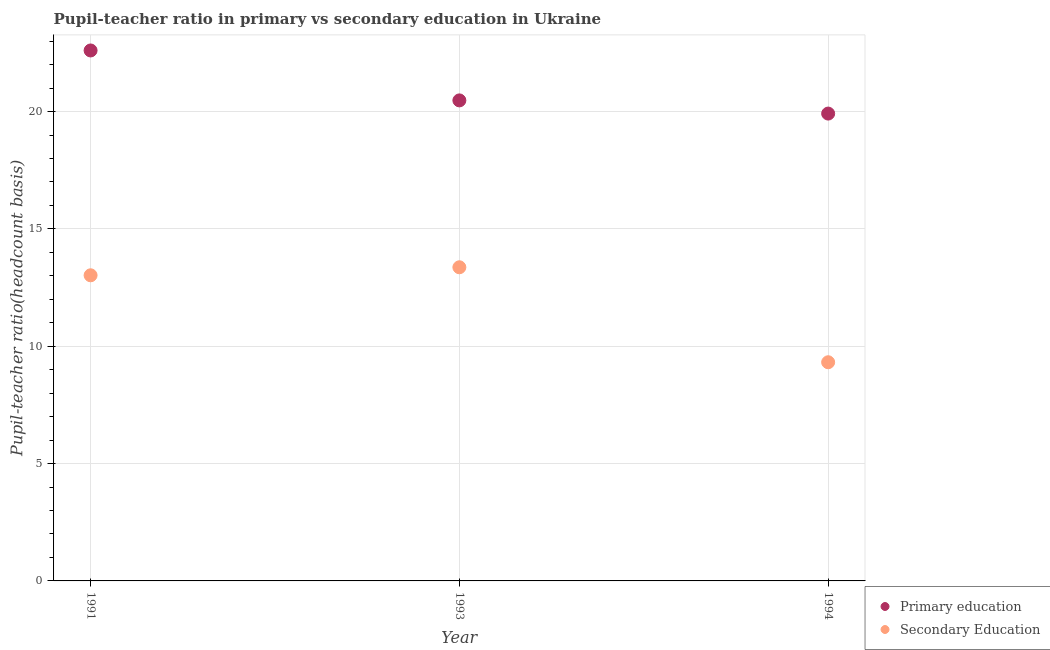How many different coloured dotlines are there?
Give a very brief answer. 2. What is the pupil-teacher ratio in primary education in 1993?
Make the answer very short. 20.48. Across all years, what is the maximum pupil teacher ratio on secondary education?
Provide a succinct answer. 13.37. Across all years, what is the minimum pupil teacher ratio on secondary education?
Give a very brief answer. 9.32. In which year was the pupil teacher ratio on secondary education minimum?
Your answer should be very brief. 1994. What is the total pupil teacher ratio on secondary education in the graph?
Provide a short and direct response. 35.71. What is the difference between the pupil teacher ratio on secondary education in 1991 and that in 1994?
Your response must be concise. 3.71. What is the difference between the pupil-teacher ratio in primary education in 1993 and the pupil teacher ratio on secondary education in 1991?
Your answer should be compact. 7.45. What is the average pupil-teacher ratio in primary education per year?
Provide a succinct answer. 21. In the year 1994, what is the difference between the pupil-teacher ratio in primary education and pupil teacher ratio on secondary education?
Your answer should be very brief. 10.6. What is the ratio of the pupil-teacher ratio in primary education in 1991 to that in 1994?
Give a very brief answer. 1.14. Is the pupil teacher ratio on secondary education in 1991 less than that in 1994?
Your answer should be compact. No. Is the difference between the pupil-teacher ratio in primary education in 1993 and 1994 greater than the difference between the pupil teacher ratio on secondary education in 1993 and 1994?
Give a very brief answer. No. What is the difference between the highest and the second highest pupil teacher ratio on secondary education?
Give a very brief answer. 0.34. What is the difference between the highest and the lowest pupil-teacher ratio in primary education?
Ensure brevity in your answer.  2.69. Is the sum of the pupil-teacher ratio in primary education in 1991 and 1994 greater than the maximum pupil teacher ratio on secondary education across all years?
Ensure brevity in your answer.  Yes. Does the pupil teacher ratio on secondary education monotonically increase over the years?
Make the answer very short. No. Are the values on the major ticks of Y-axis written in scientific E-notation?
Offer a terse response. No. Does the graph contain any zero values?
Your response must be concise. No. Where does the legend appear in the graph?
Your response must be concise. Bottom right. How many legend labels are there?
Offer a terse response. 2. What is the title of the graph?
Keep it short and to the point. Pupil-teacher ratio in primary vs secondary education in Ukraine. What is the label or title of the Y-axis?
Give a very brief answer. Pupil-teacher ratio(headcount basis). What is the Pupil-teacher ratio(headcount basis) in Primary education in 1991?
Keep it short and to the point. 22.6. What is the Pupil-teacher ratio(headcount basis) of Secondary Education in 1991?
Your answer should be compact. 13.02. What is the Pupil-teacher ratio(headcount basis) of Primary education in 1993?
Provide a short and direct response. 20.48. What is the Pupil-teacher ratio(headcount basis) in Secondary Education in 1993?
Your answer should be very brief. 13.37. What is the Pupil-teacher ratio(headcount basis) of Primary education in 1994?
Your response must be concise. 19.92. What is the Pupil-teacher ratio(headcount basis) in Secondary Education in 1994?
Make the answer very short. 9.32. Across all years, what is the maximum Pupil-teacher ratio(headcount basis) in Primary education?
Offer a terse response. 22.6. Across all years, what is the maximum Pupil-teacher ratio(headcount basis) in Secondary Education?
Offer a very short reply. 13.37. Across all years, what is the minimum Pupil-teacher ratio(headcount basis) of Primary education?
Make the answer very short. 19.92. Across all years, what is the minimum Pupil-teacher ratio(headcount basis) in Secondary Education?
Your answer should be very brief. 9.32. What is the total Pupil-teacher ratio(headcount basis) in Primary education in the graph?
Make the answer very short. 63. What is the total Pupil-teacher ratio(headcount basis) in Secondary Education in the graph?
Your answer should be compact. 35.71. What is the difference between the Pupil-teacher ratio(headcount basis) of Primary education in 1991 and that in 1993?
Provide a short and direct response. 2.13. What is the difference between the Pupil-teacher ratio(headcount basis) in Secondary Education in 1991 and that in 1993?
Your response must be concise. -0.34. What is the difference between the Pupil-teacher ratio(headcount basis) of Primary education in 1991 and that in 1994?
Provide a short and direct response. 2.69. What is the difference between the Pupil-teacher ratio(headcount basis) of Secondary Education in 1991 and that in 1994?
Give a very brief answer. 3.71. What is the difference between the Pupil-teacher ratio(headcount basis) of Primary education in 1993 and that in 1994?
Make the answer very short. 0.56. What is the difference between the Pupil-teacher ratio(headcount basis) of Secondary Education in 1993 and that in 1994?
Provide a succinct answer. 4.05. What is the difference between the Pupil-teacher ratio(headcount basis) of Primary education in 1991 and the Pupil-teacher ratio(headcount basis) of Secondary Education in 1993?
Keep it short and to the point. 9.24. What is the difference between the Pupil-teacher ratio(headcount basis) in Primary education in 1991 and the Pupil-teacher ratio(headcount basis) in Secondary Education in 1994?
Offer a very short reply. 13.29. What is the difference between the Pupil-teacher ratio(headcount basis) in Primary education in 1993 and the Pupil-teacher ratio(headcount basis) in Secondary Education in 1994?
Provide a short and direct response. 11.16. What is the average Pupil-teacher ratio(headcount basis) in Primary education per year?
Your answer should be compact. 21. What is the average Pupil-teacher ratio(headcount basis) of Secondary Education per year?
Your response must be concise. 11.9. In the year 1991, what is the difference between the Pupil-teacher ratio(headcount basis) in Primary education and Pupil-teacher ratio(headcount basis) in Secondary Education?
Offer a very short reply. 9.58. In the year 1993, what is the difference between the Pupil-teacher ratio(headcount basis) of Primary education and Pupil-teacher ratio(headcount basis) of Secondary Education?
Make the answer very short. 7.11. In the year 1994, what is the difference between the Pupil-teacher ratio(headcount basis) of Primary education and Pupil-teacher ratio(headcount basis) of Secondary Education?
Your answer should be compact. 10.6. What is the ratio of the Pupil-teacher ratio(headcount basis) in Primary education in 1991 to that in 1993?
Make the answer very short. 1.1. What is the ratio of the Pupil-teacher ratio(headcount basis) in Secondary Education in 1991 to that in 1993?
Give a very brief answer. 0.97. What is the ratio of the Pupil-teacher ratio(headcount basis) of Primary education in 1991 to that in 1994?
Your response must be concise. 1.14. What is the ratio of the Pupil-teacher ratio(headcount basis) of Secondary Education in 1991 to that in 1994?
Provide a short and direct response. 1.4. What is the ratio of the Pupil-teacher ratio(headcount basis) in Primary education in 1993 to that in 1994?
Make the answer very short. 1.03. What is the ratio of the Pupil-teacher ratio(headcount basis) of Secondary Education in 1993 to that in 1994?
Offer a terse response. 1.43. What is the difference between the highest and the second highest Pupil-teacher ratio(headcount basis) of Primary education?
Your answer should be very brief. 2.13. What is the difference between the highest and the second highest Pupil-teacher ratio(headcount basis) of Secondary Education?
Provide a short and direct response. 0.34. What is the difference between the highest and the lowest Pupil-teacher ratio(headcount basis) in Primary education?
Offer a terse response. 2.69. What is the difference between the highest and the lowest Pupil-teacher ratio(headcount basis) in Secondary Education?
Give a very brief answer. 4.05. 